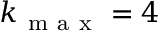Convert formula to latex. <formula><loc_0><loc_0><loc_500><loc_500>k _ { m a x } = 4</formula> 